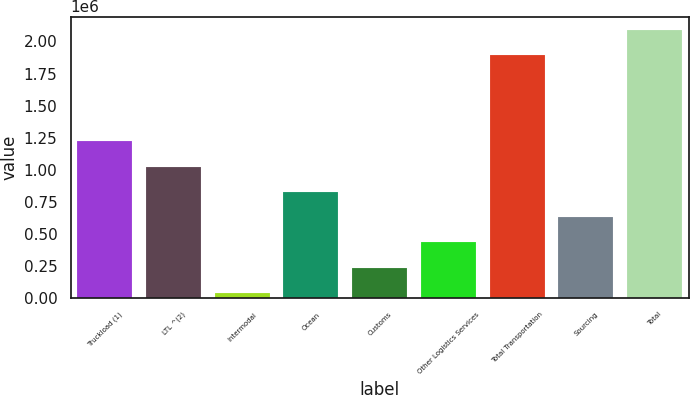<chart> <loc_0><loc_0><loc_500><loc_500><bar_chart><fcel>Truckload (1)<fcel>LTL ^(2)<fcel>Intermodal<fcel>Ocean<fcel>Customs<fcel>Other Logistics Services<fcel>Total Transportation<fcel>Sourcing<fcel>Total<nl><fcel>1.22084e+06<fcel>1.02414e+06<fcel>40631<fcel>827439<fcel>237333<fcel>434035<fcel>1.89211e+06<fcel>630737<fcel>2.08881e+06<nl></chart> 